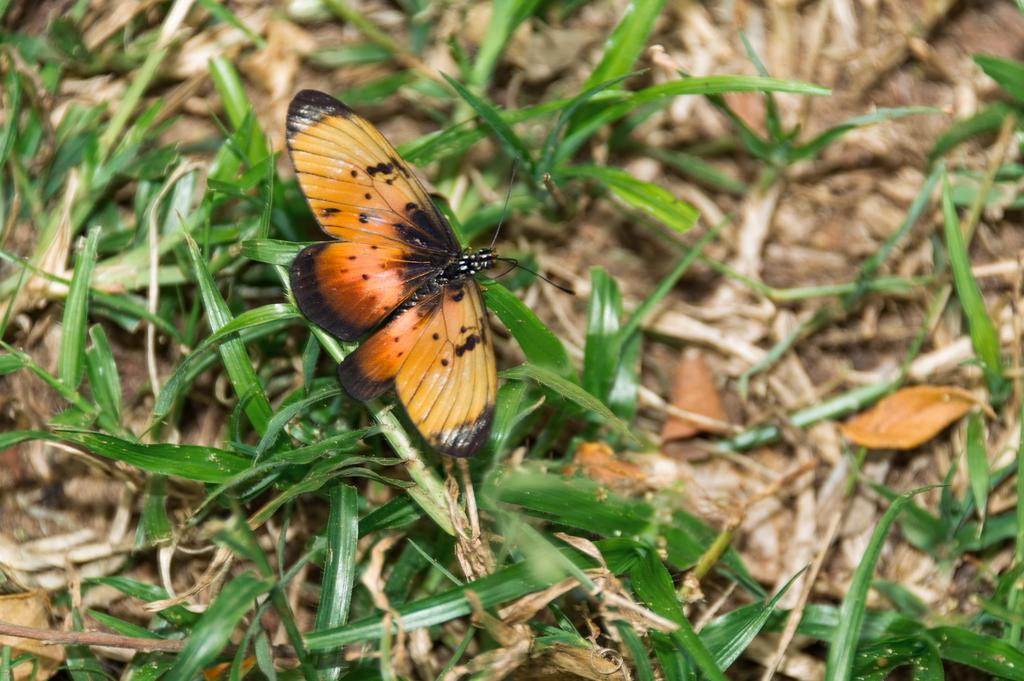What is the main subject of the image? There is a butterfly in the image. What colors can be seen on the butterfly? The butterfly has yellow and black colors. Where is the butterfly located in the image? The butterfly is sitting on the grass. What type of jelly can be seen in the image? There is no jelly present in the image; it features a butterfly sitting on the grass. Is there a park visible in the image? The provided facts do not mention a park, and there is no indication of a park in the image. 